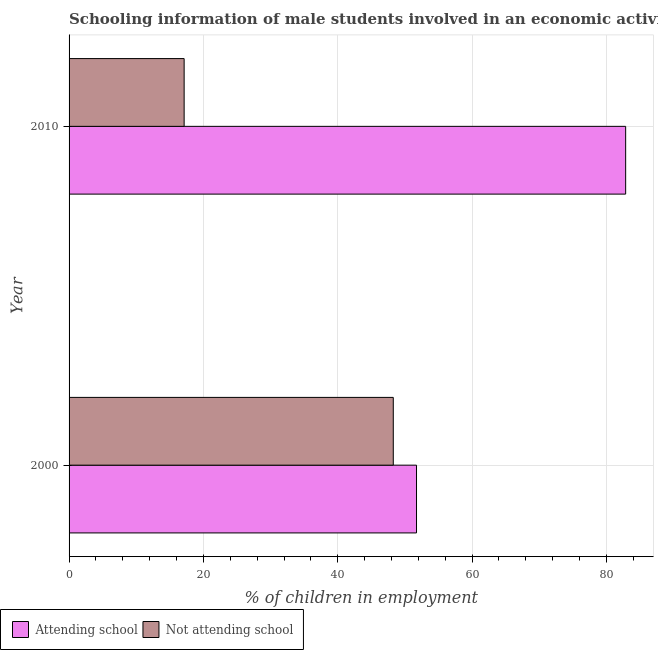How many different coloured bars are there?
Your answer should be compact. 2. How many groups of bars are there?
Your response must be concise. 2. Are the number of bars per tick equal to the number of legend labels?
Your response must be concise. Yes. How many bars are there on the 1st tick from the top?
Give a very brief answer. 2. What is the label of the 1st group of bars from the top?
Make the answer very short. 2010. What is the percentage of employed males who are attending school in 2000?
Your answer should be very brief. 51.73. Across all years, what is the maximum percentage of employed males who are attending school?
Ensure brevity in your answer.  82.87. Across all years, what is the minimum percentage of employed males who are attending school?
Provide a short and direct response. 51.73. In which year was the percentage of employed males who are not attending school maximum?
Offer a very short reply. 2000. What is the total percentage of employed males who are attending school in the graph?
Your response must be concise. 134.6. What is the difference between the percentage of employed males who are attending school in 2000 and that in 2010?
Offer a terse response. -31.14. What is the difference between the percentage of employed males who are not attending school in 2010 and the percentage of employed males who are attending school in 2000?
Provide a short and direct response. -34.6. What is the average percentage of employed males who are attending school per year?
Your answer should be very brief. 67.3. In the year 2010, what is the difference between the percentage of employed males who are attending school and percentage of employed males who are not attending school?
Provide a succinct answer. 65.74. What is the ratio of the percentage of employed males who are not attending school in 2000 to that in 2010?
Offer a very short reply. 2.82. In how many years, is the percentage of employed males who are attending school greater than the average percentage of employed males who are attending school taken over all years?
Offer a very short reply. 1. What does the 1st bar from the top in 2010 represents?
Your answer should be compact. Not attending school. What does the 1st bar from the bottom in 2000 represents?
Provide a short and direct response. Attending school. Are all the bars in the graph horizontal?
Your answer should be very brief. Yes. How many years are there in the graph?
Your answer should be compact. 2. Does the graph contain any zero values?
Your answer should be very brief. No. Where does the legend appear in the graph?
Provide a short and direct response. Bottom left. How many legend labels are there?
Give a very brief answer. 2. What is the title of the graph?
Ensure brevity in your answer.  Schooling information of male students involved in an economic activity in Central African Republic. Does "Gasoline" appear as one of the legend labels in the graph?
Give a very brief answer. No. What is the label or title of the X-axis?
Your answer should be very brief. % of children in employment. What is the label or title of the Y-axis?
Ensure brevity in your answer.  Year. What is the % of children in employment of Attending school in 2000?
Your answer should be compact. 51.73. What is the % of children in employment in Not attending school in 2000?
Provide a short and direct response. 48.27. What is the % of children in employment of Attending school in 2010?
Offer a terse response. 82.87. What is the % of children in employment in Not attending school in 2010?
Offer a very short reply. 17.13. Across all years, what is the maximum % of children in employment in Attending school?
Make the answer very short. 82.87. Across all years, what is the maximum % of children in employment in Not attending school?
Offer a very short reply. 48.27. Across all years, what is the minimum % of children in employment of Attending school?
Offer a terse response. 51.73. Across all years, what is the minimum % of children in employment of Not attending school?
Provide a succinct answer. 17.13. What is the total % of children in employment in Attending school in the graph?
Ensure brevity in your answer.  134.6. What is the total % of children in employment of Not attending school in the graph?
Keep it short and to the point. 65.4. What is the difference between the % of children in employment in Attending school in 2000 and that in 2010?
Your answer should be very brief. -31.14. What is the difference between the % of children in employment of Not attending school in 2000 and that in 2010?
Make the answer very short. 31.14. What is the difference between the % of children in employment in Attending school in 2000 and the % of children in employment in Not attending school in 2010?
Your answer should be compact. 34.6. What is the average % of children in employment of Attending school per year?
Your answer should be compact. 67.3. What is the average % of children in employment in Not attending school per year?
Keep it short and to the point. 32.7. In the year 2000, what is the difference between the % of children in employment of Attending school and % of children in employment of Not attending school?
Offer a very short reply. 3.46. In the year 2010, what is the difference between the % of children in employment in Attending school and % of children in employment in Not attending school?
Your response must be concise. 65.74. What is the ratio of the % of children in employment in Attending school in 2000 to that in 2010?
Ensure brevity in your answer.  0.62. What is the ratio of the % of children in employment in Not attending school in 2000 to that in 2010?
Give a very brief answer. 2.82. What is the difference between the highest and the second highest % of children in employment of Attending school?
Give a very brief answer. 31.14. What is the difference between the highest and the second highest % of children in employment of Not attending school?
Provide a succinct answer. 31.14. What is the difference between the highest and the lowest % of children in employment of Attending school?
Provide a succinct answer. 31.14. What is the difference between the highest and the lowest % of children in employment in Not attending school?
Provide a succinct answer. 31.14. 